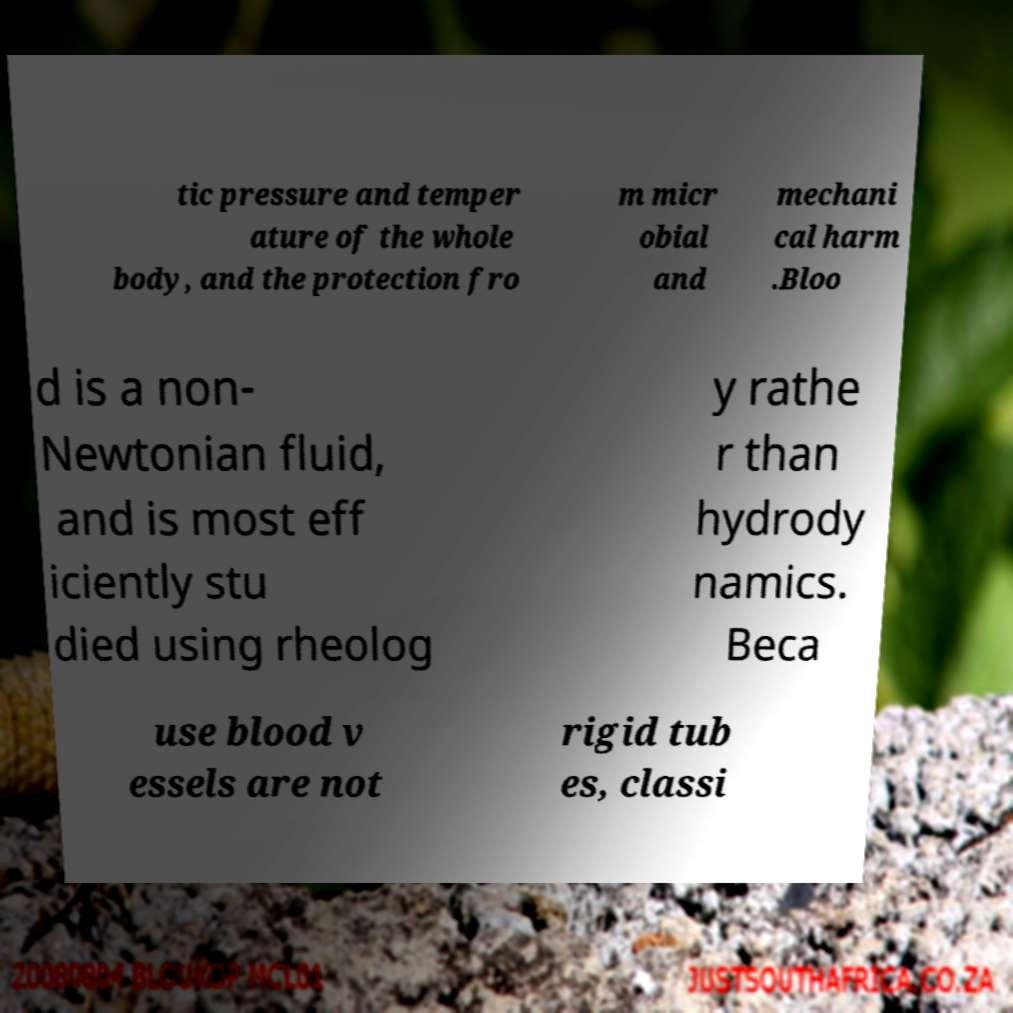For documentation purposes, I need the text within this image transcribed. Could you provide that? tic pressure and temper ature of the whole body, and the protection fro m micr obial and mechani cal harm .Bloo d is a non- Newtonian fluid, and is most eff iciently stu died using rheolog y rathe r than hydrody namics. Beca use blood v essels are not rigid tub es, classi 